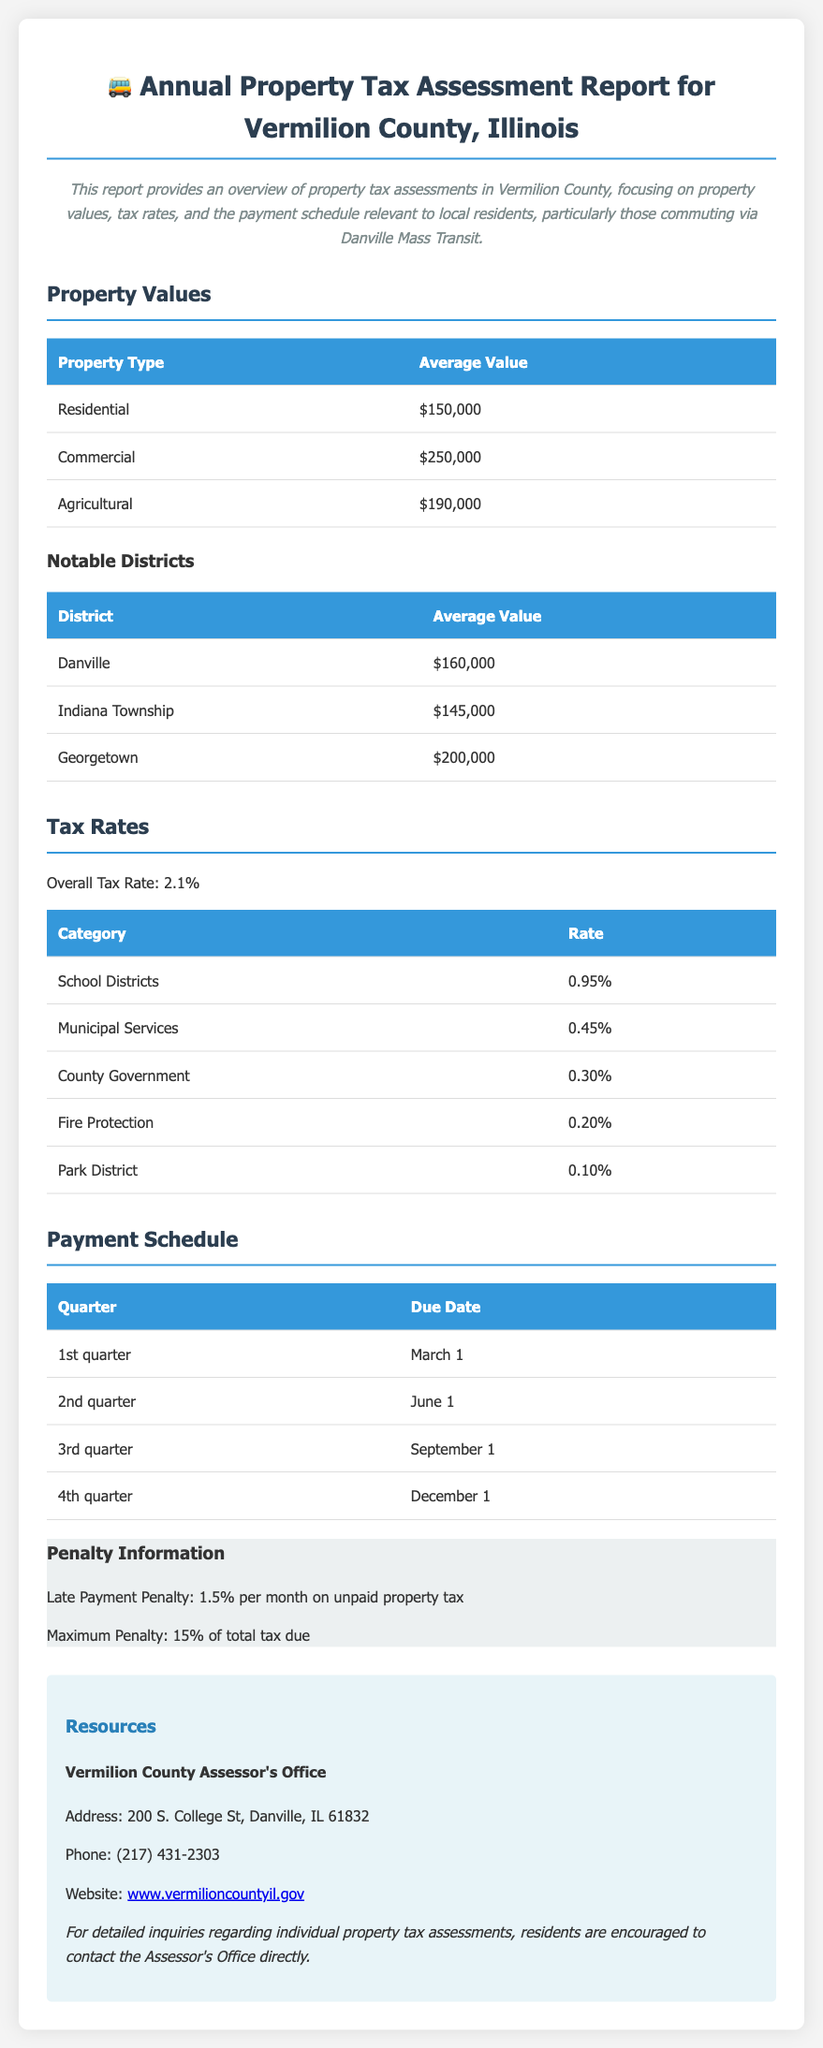What is the average value of residential properties? The average value of residential properties is directly stated in the document under property values.
Answer: $150,000 What is the overall tax rate? The overall tax rate is explicitly mentioned in the tax rates section of the document.
Answer: 2.1% When is the due date for the 2nd quarter payment? The due date for the 2nd quarter payment can be found in the payment schedule table.
Answer: June 1 What is the average property value in Danville? The average property value in Danville is listed in the notable districts table.
Answer: $160,000 What penalty is applied for late payments? The penalty for late payments is specified in the penalty information section of the document.
Answer: 1.5% per month Which district has the highest average property value? The district with the highest average property value is identified in the notable districts table.
Answer: Georgetown What is the maximum penalty for unpaid property tax? The maximum penalty for unpaid property tax is mentioned in the highlight section regarding penalty information.
Answer: 15% How many categories are listed for tax rates? The number of categories for tax rates is counted from the corresponding table in the document.
Answer: 5 What is the address of the Vermilion County Assessor's Office? The address details of the Vermilion County Assessor's Office are included in the resources section.
Answer: 200 S. College St, Danville, IL 61832 